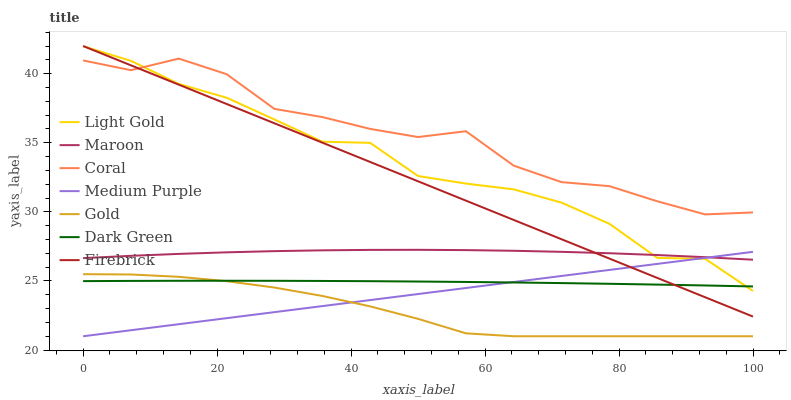Does Gold have the minimum area under the curve?
Answer yes or no. Yes. Does Coral have the maximum area under the curve?
Answer yes or no. Yes. Does Maroon have the minimum area under the curve?
Answer yes or no. No. Does Maroon have the maximum area under the curve?
Answer yes or no. No. Is Medium Purple the smoothest?
Answer yes or no. Yes. Is Coral the roughest?
Answer yes or no. Yes. Is Maroon the smoothest?
Answer yes or no. No. Is Maroon the roughest?
Answer yes or no. No. Does Gold have the lowest value?
Answer yes or no. Yes. Does Maroon have the lowest value?
Answer yes or no. No. Does Firebrick have the highest value?
Answer yes or no. Yes. Does Coral have the highest value?
Answer yes or no. No. Is Maroon less than Coral?
Answer yes or no. Yes. Is Coral greater than Maroon?
Answer yes or no. Yes. Does Maroon intersect Firebrick?
Answer yes or no. Yes. Is Maroon less than Firebrick?
Answer yes or no. No. Is Maroon greater than Firebrick?
Answer yes or no. No. Does Maroon intersect Coral?
Answer yes or no. No. 